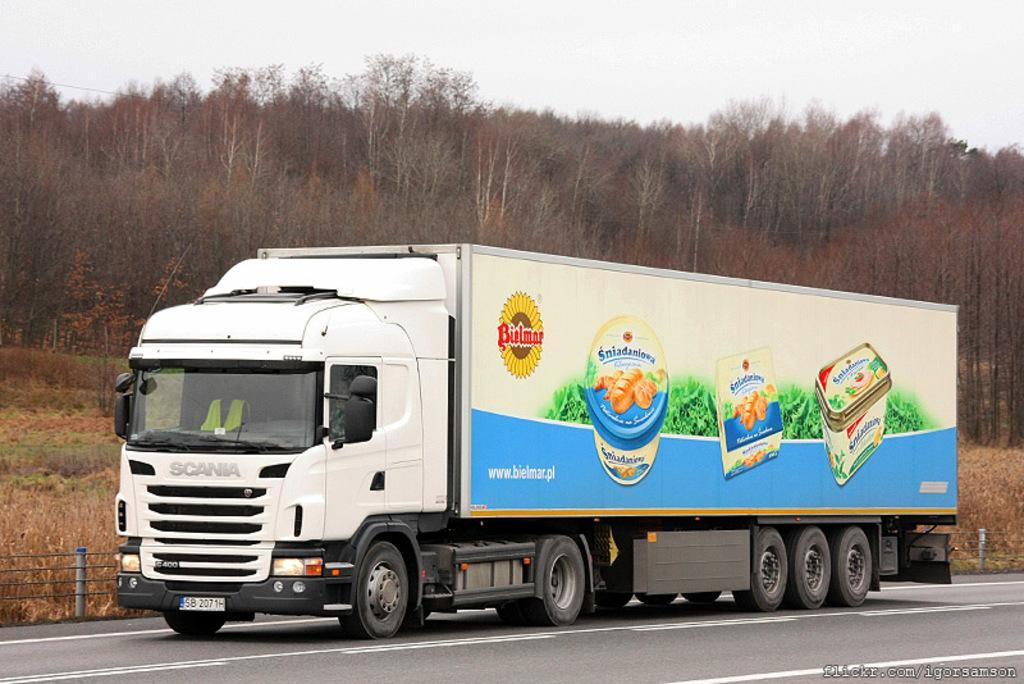Describe this image in one or two sentences. In the center of the image we can see truck on the road. In the background we can see trees, plants, grass and sky. 